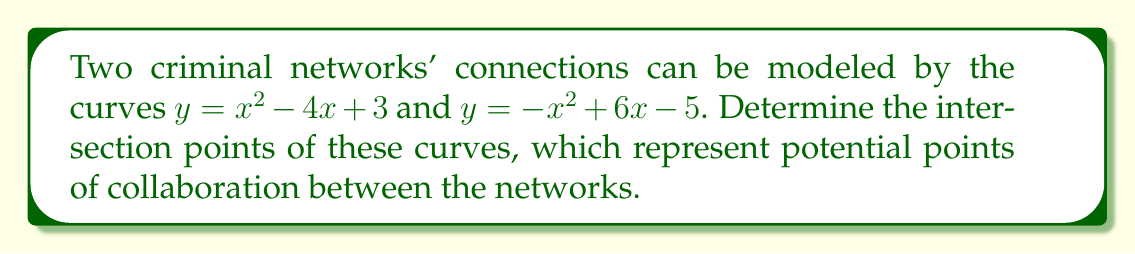Help me with this question. To find the intersection points, we need to solve the system of equations:

$$\begin{cases}
y = x^2 - 4x + 3 \\
y = -x^2 + 6x - 5
\end{cases}$$

Step 1: Set the equations equal to each other:
$x^2 - 4x + 3 = -x^2 + 6x - 5$

Step 2: Rearrange all terms to one side:
$2x^2 - 10x + 8 = 0$

Step 3: Divide all terms by 2 to simplify:
$x^2 - 5x + 4 = 0$

Step 4: Use the quadratic formula $x = \frac{-b \pm \sqrt{b^2 - 4ac}}{2a}$, where $a=1$, $b=-5$, and $c=4$:

$x = \frac{5 \pm \sqrt{25 - 16}}{2} = \frac{5 \pm 3}{2}$

Step 5: Solve for x:
$x_1 = \frac{5 + 3}{2} = 4$ and $x_2 = \frac{5 - 3}{2} = 1$

Step 6: Find the corresponding y-values by substituting x into either original equation:

For $x_1 = 4$: $y = 4^2 - 4(4) + 3 = 16 - 16 + 3 = 3$
For $x_2 = 1$: $y = 1^2 - 4(1) + 3 = 1 - 4 + 3 = 0$

Therefore, the intersection points are (4, 3) and (1, 0).
Answer: (4, 3) and (1, 0) 